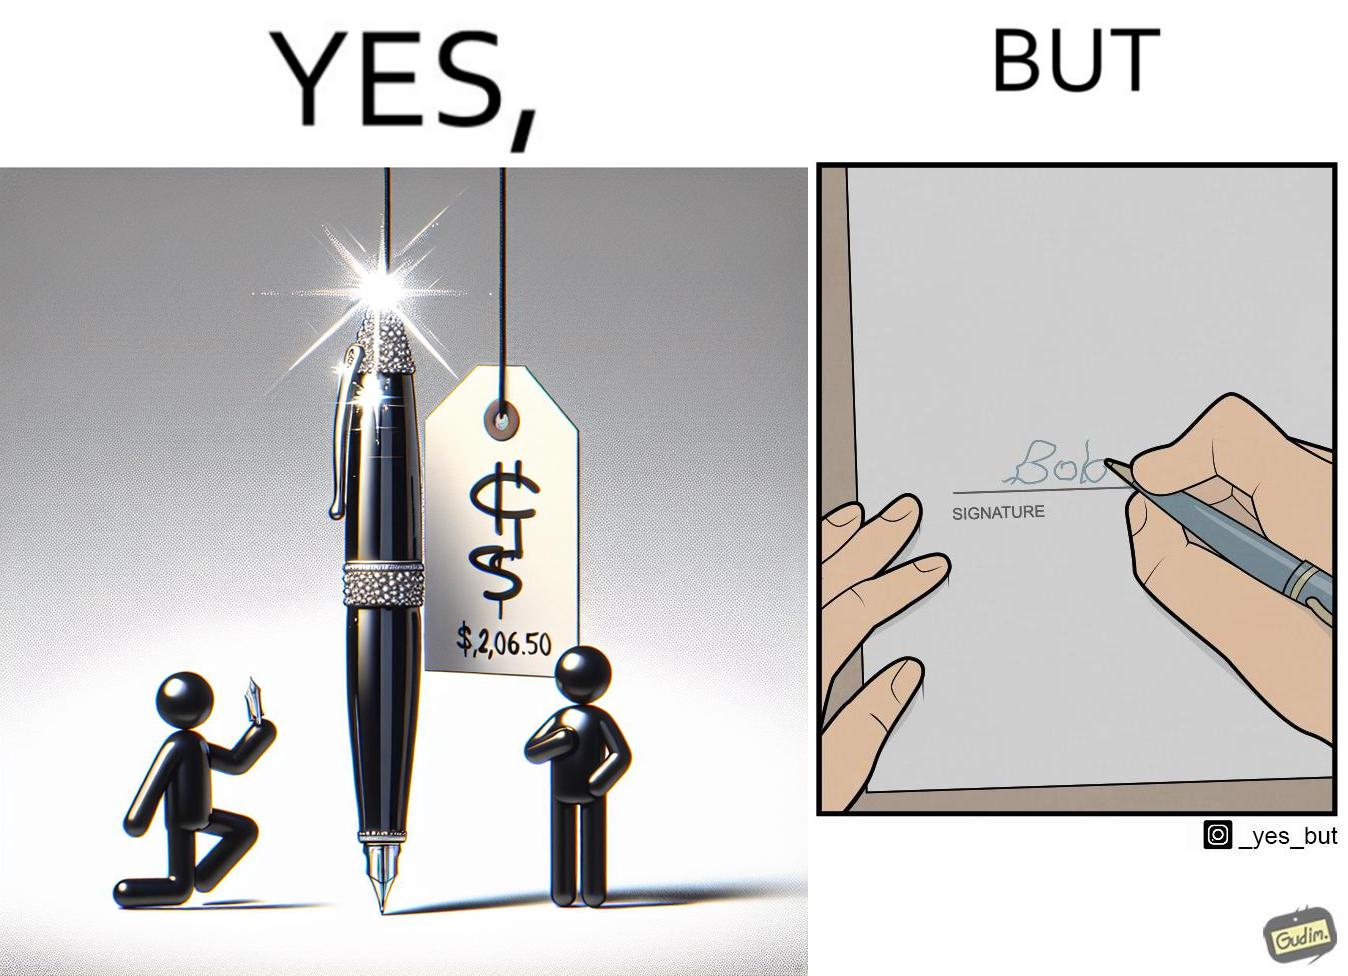Describe the contrast between the left and right parts of this image. In the left part of the image: a new sparkling pen at some sale priced at around $2,065.00 In the right part of the image: someone with not so good handwriting giving his signature at some paper 